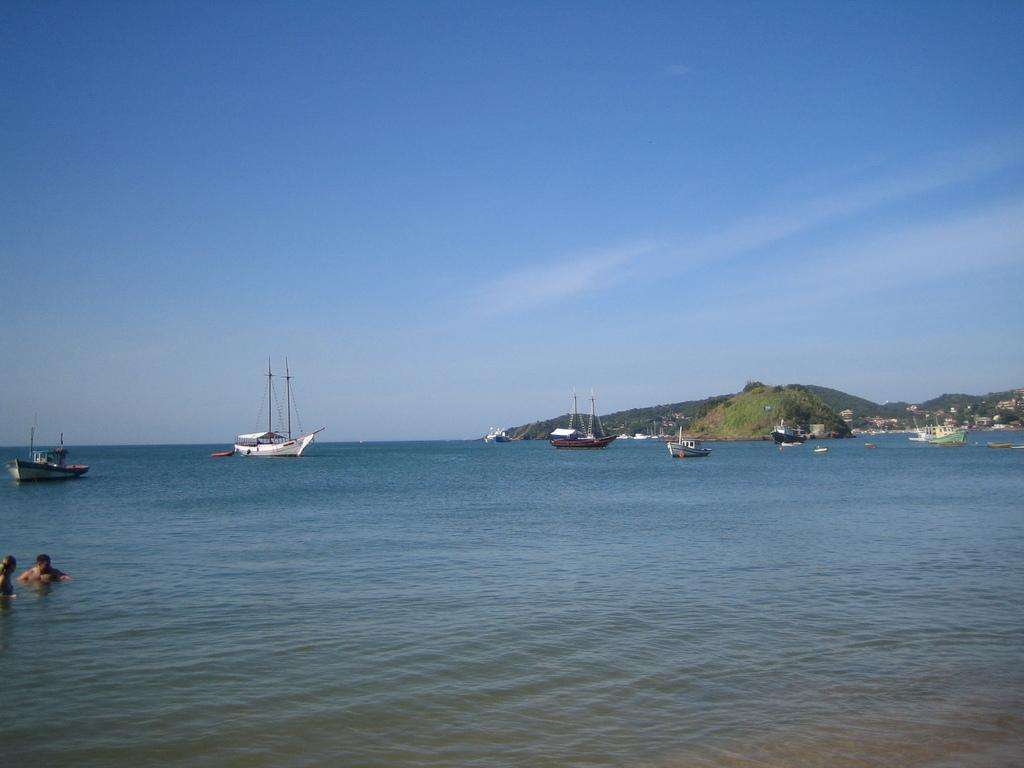What is the main subject of the image? The image depicts a sea. What types of watercraft can be seen on the sea? There are ships and boats sailing on the sea. What are the two people on the left side of the image doing? They are swimming in the water. What can be seen in the background of the image? There are mountains in the background. What type of string can be seen connecting the mountains in the image? There is no string present in the image; it only shows a sea with ships, boats, and people swimming. 